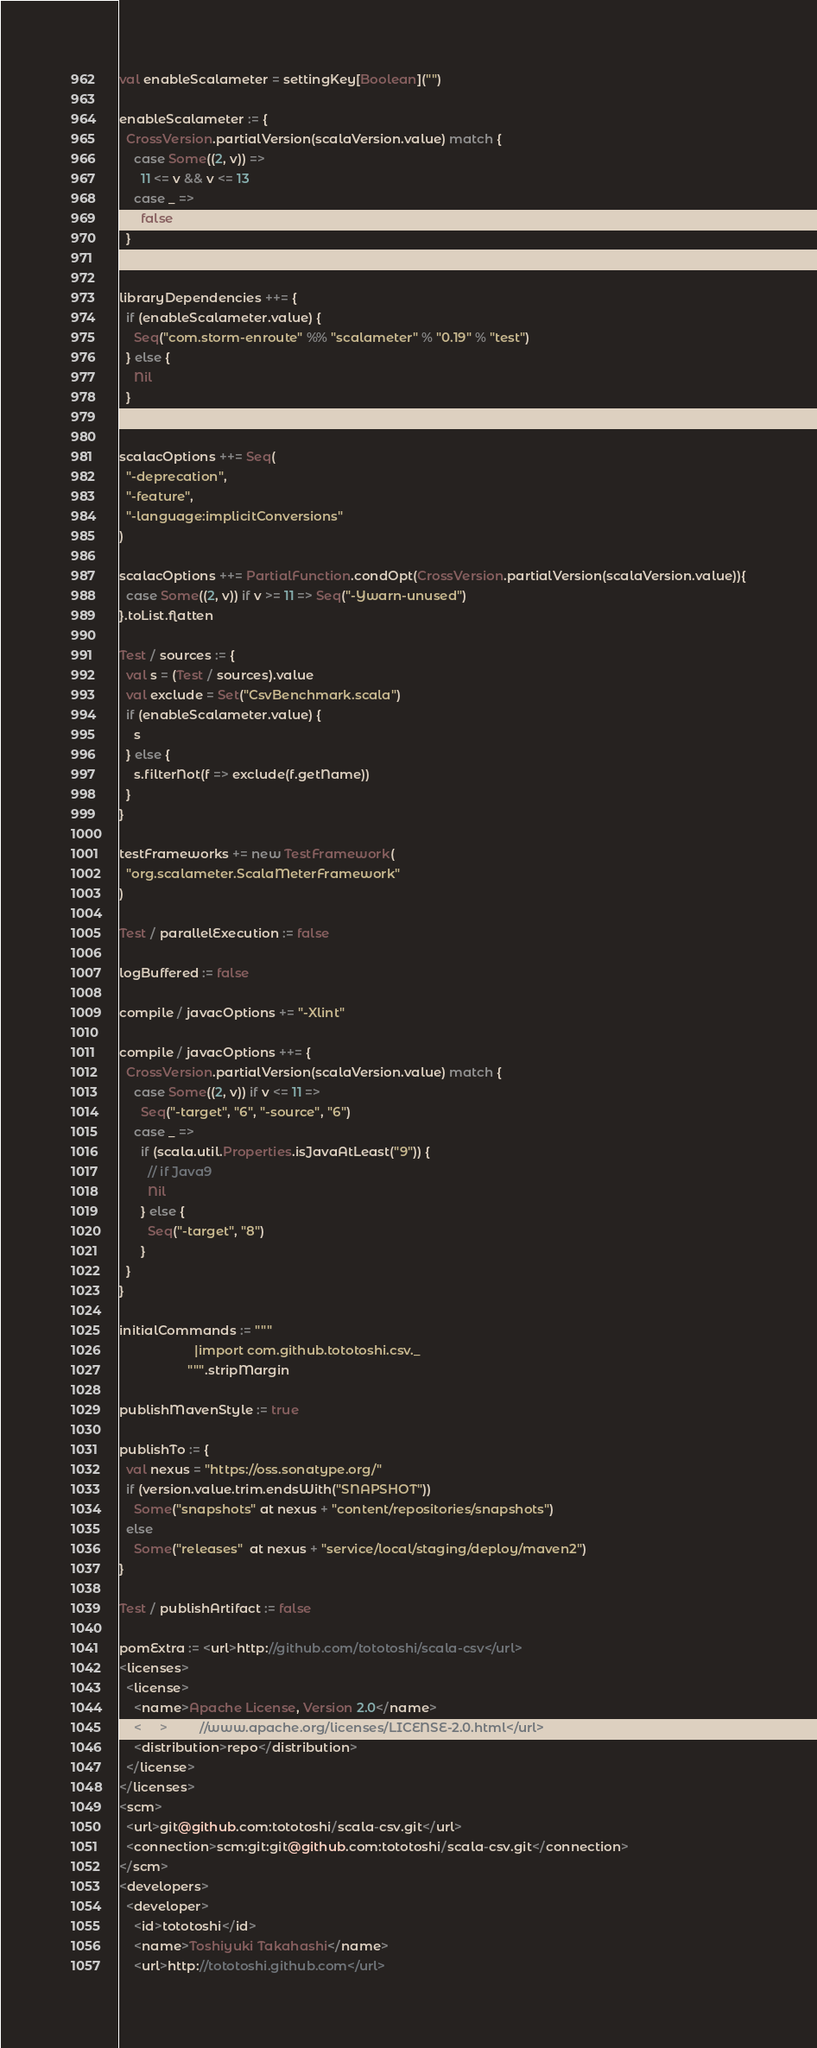<code> <loc_0><loc_0><loc_500><loc_500><_Scala_>val enableScalameter = settingKey[Boolean]("")

enableScalameter := {
  CrossVersion.partialVersion(scalaVersion.value) match {
    case Some((2, v)) =>
      11 <= v && v <= 13
    case _ =>
      false
  }
}

libraryDependencies ++= {
  if (enableScalameter.value) {
    Seq("com.storm-enroute" %% "scalameter" % "0.19" % "test")
  } else {
    Nil
  }
}

scalacOptions ++= Seq(
  "-deprecation",
  "-feature",
  "-language:implicitConversions"
)

scalacOptions ++= PartialFunction.condOpt(CrossVersion.partialVersion(scalaVersion.value)){
  case Some((2, v)) if v >= 11 => Seq("-Ywarn-unused")
}.toList.flatten

Test / sources := {
  val s = (Test / sources).value
  val exclude = Set("CsvBenchmark.scala")
  if (enableScalameter.value) {
    s
  } else {
    s.filterNot(f => exclude(f.getName))
  }
}

testFrameworks += new TestFramework(
  "org.scalameter.ScalaMeterFramework"
)

Test / parallelExecution := false

logBuffered := false

compile / javacOptions += "-Xlint"

compile / javacOptions ++= {
  CrossVersion.partialVersion(scalaVersion.value) match {
    case Some((2, v)) if v <= 11 =>
      Seq("-target", "6", "-source", "6")
    case _ =>
      if (scala.util.Properties.isJavaAtLeast("9")) {
        // if Java9
        Nil
      } else {
        Seq("-target", "8")
      }
  }
}

initialCommands := """
                     |import com.github.tototoshi.csv._
                   """.stripMargin

publishMavenStyle := true

publishTo := {
  val nexus = "https://oss.sonatype.org/"
  if (version.value.trim.endsWith("SNAPSHOT"))
    Some("snapshots" at nexus + "content/repositories/snapshots")
  else
    Some("releases"  at nexus + "service/local/staging/deploy/maven2")
}

Test / publishArtifact := false

pomExtra := <url>http://github.com/tototoshi/scala-csv</url>
<licenses>
  <license>
    <name>Apache License, Version 2.0</name>
    <url>http://www.apache.org/licenses/LICENSE-2.0.html</url>
    <distribution>repo</distribution>
  </license>
</licenses>
<scm>
  <url>git@github.com:tototoshi/scala-csv.git</url>
  <connection>scm:git:git@github.com:tototoshi/scala-csv.git</connection>
</scm>
<developers>
  <developer>
    <id>tototoshi</id>
    <name>Toshiyuki Takahashi</name>
    <url>http://tototoshi.github.com</url></code> 